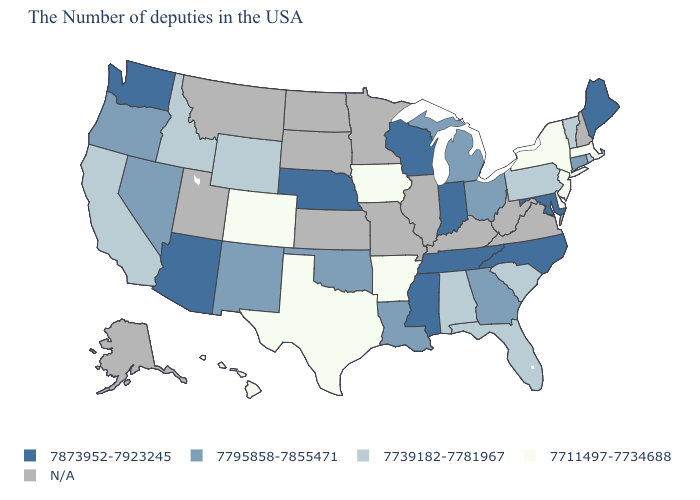Which states have the lowest value in the USA?
Give a very brief answer. Massachusetts, New York, New Jersey, Delaware, Arkansas, Iowa, Texas, Colorado, Hawaii. What is the value of Hawaii?
Write a very short answer. 7711497-7734688. What is the highest value in states that border South Carolina?
Give a very brief answer. 7873952-7923245. Among the states that border Virginia , which have the highest value?
Keep it brief. Maryland, North Carolina, Tennessee. Name the states that have a value in the range 7739182-7781967?
Quick response, please. Rhode Island, Vermont, Pennsylvania, South Carolina, Florida, Alabama, Wyoming, Idaho, California. What is the lowest value in the USA?
Concise answer only. 7711497-7734688. Does New Mexico have the highest value in the USA?
Quick response, please. No. Does the map have missing data?
Write a very short answer. Yes. What is the value of New Jersey?
Keep it brief. 7711497-7734688. Does Arkansas have the lowest value in the USA?
Give a very brief answer. Yes. Is the legend a continuous bar?
Give a very brief answer. No. What is the value of Delaware?
Concise answer only. 7711497-7734688. Name the states that have a value in the range 7739182-7781967?
Give a very brief answer. Rhode Island, Vermont, Pennsylvania, South Carolina, Florida, Alabama, Wyoming, Idaho, California. Does Pennsylvania have the lowest value in the Northeast?
Give a very brief answer. No. 